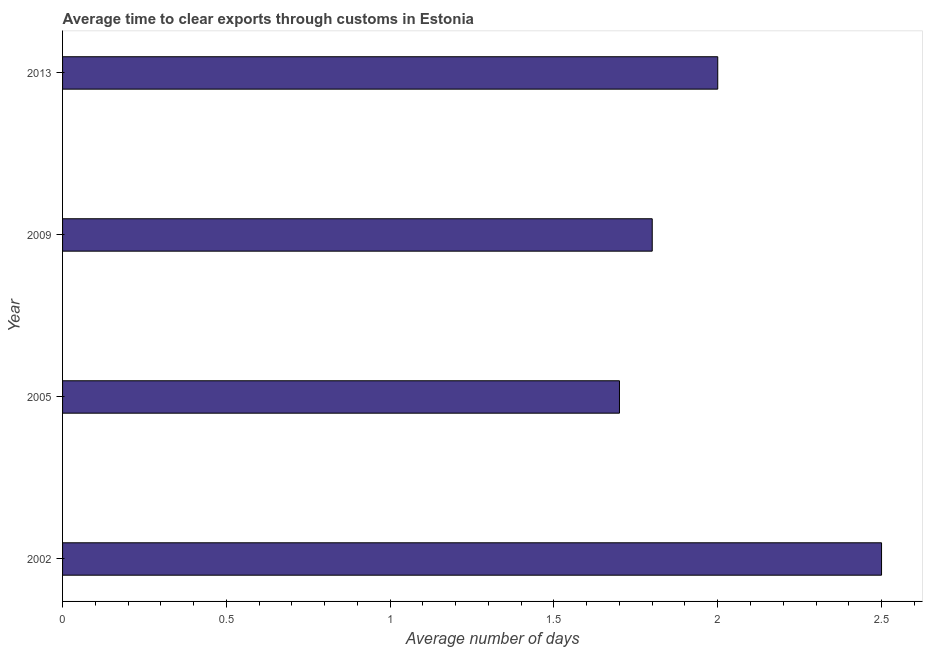Does the graph contain any zero values?
Your response must be concise. No. What is the title of the graph?
Provide a succinct answer. Average time to clear exports through customs in Estonia. What is the label or title of the X-axis?
Your answer should be compact. Average number of days. What is the label or title of the Y-axis?
Offer a very short reply. Year. What is the time to clear exports through customs in 2002?
Provide a short and direct response. 2.5. Across all years, what is the maximum time to clear exports through customs?
Your response must be concise. 2.5. What is the sum of the time to clear exports through customs?
Your answer should be compact. 8. What is the ratio of the time to clear exports through customs in 2002 to that in 2005?
Ensure brevity in your answer.  1.47. Is the difference between the time to clear exports through customs in 2005 and 2013 greater than the difference between any two years?
Keep it short and to the point. No. What is the difference between the highest and the second highest time to clear exports through customs?
Offer a very short reply. 0.5. Is the sum of the time to clear exports through customs in 2009 and 2013 greater than the maximum time to clear exports through customs across all years?
Keep it short and to the point. Yes. What is the difference between the highest and the lowest time to clear exports through customs?
Provide a short and direct response. 0.8. In how many years, is the time to clear exports through customs greater than the average time to clear exports through customs taken over all years?
Ensure brevity in your answer.  1. How many bars are there?
Ensure brevity in your answer.  4. Are all the bars in the graph horizontal?
Offer a terse response. Yes. How many years are there in the graph?
Provide a succinct answer. 4. Are the values on the major ticks of X-axis written in scientific E-notation?
Your response must be concise. No. What is the difference between the Average number of days in 2002 and 2009?
Provide a succinct answer. 0.7. What is the difference between the Average number of days in 2005 and 2013?
Give a very brief answer. -0.3. What is the ratio of the Average number of days in 2002 to that in 2005?
Provide a succinct answer. 1.47. What is the ratio of the Average number of days in 2002 to that in 2009?
Give a very brief answer. 1.39. What is the ratio of the Average number of days in 2005 to that in 2009?
Make the answer very short. 0.94. What is the ratio of the Average number of days in 2005 to that in 2013?
Offer a very short reply. 0.85. 